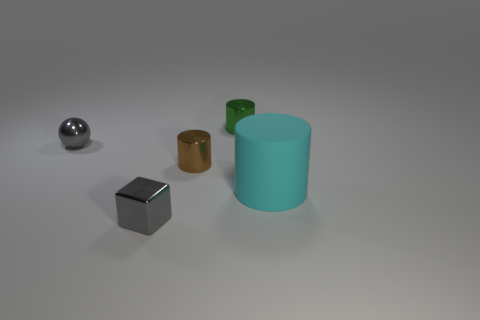How would you classify the style or theme of this collection of objects? The collection of objects presents a minimalist style with clean lines and simple geometric shapes. The theme could be interpreted as a study in form and materiality, with each object conveying the essential characteristics of its shape and texture.  Do you think there's a specific purpose for this arrangement? This arrangement could serve as a visual reference for an art or design project, aiming to showcase the interplay of different shapes, sizes, and materials under uniform lighting to either study their properties or for aesthetic examination. 